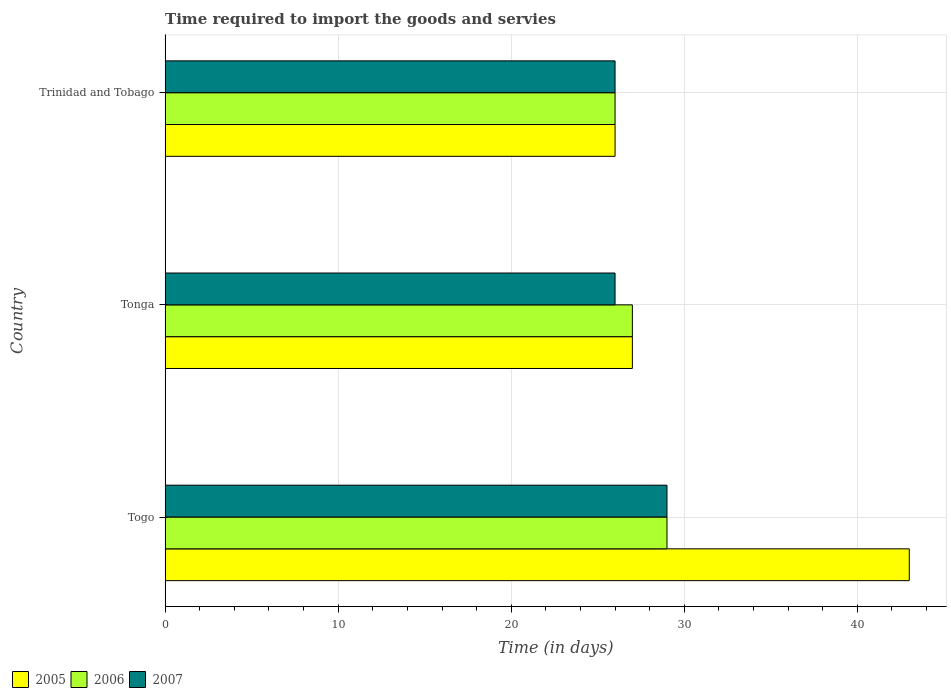How many groups of bars are there?
Your response must be concise. 3. Are the number of bars per tick equal to the number of legend labels?
Make the answer very short. Yes. Are the number of bars on each tick of the Y-axis equal?
Your response must be concise. Yes. How many bars are there on the 3rd tick from the top?
Offer a very short reply. 3. What is the label of the 3rd group of bars from the top?
Offer a terse response. Togo. In which country was the number of days required to import the goods and services in 2005 maximum?
Your response must be concise. Togo. In which country was the number of days required to import the goods and services in 2005 minimum?
Ensure brevity in your answer.  Trinidad and Tobago. What is the difference between the number of days required to import the goods and services in 2006 in Togo and that in Tonga?
Make the answer very short. 2. What is the average number of days required to import the goods and services in 2007 per country?
Your answer should be compact. 27. What is the difference between the number of days required to import the goods and services in 2005 and number of days required to import the goods and services in 2007 in Togo?
Keep it short and to the point. 14. What is the ratio of the number of days required to import the goods and services in 2006 in Togo to that in Tonga?
Make the answer very short. 1.07. Is the number of days required to import the goods and services in 2007 in Tonga less than that in Trinidad and Tobago?
Ensure brevity in your answer.  No. Is the difference between the number of days required to import the goods and services in 2005 in Togo and Trinidad and Tobago greater than the difference between the number of days required to import the goods and services in 2007 in Togo and Trinidad and Tobago?
Give a very brief answer. Yes. What is the difference between the highest and the lowest number of days required to import the goods and services in 2005?
Give a very brief answer. 17. In how many countries, is the number of days required to import the goods and services in 2005 greater than the average number of days required to import the goods and services in 2005 taken over all countries?
Ensure brevity in your answer.  1. What does the 1st bar from the top in Tonga represents?
Make the answer very short. 2007. Are all the bars in the graph horizontal?
Provide a short and direct response. Yes. How many countries are there in the graph?
Give a very brief answer. 3. Does the graph contain any zero values?
Your answer should be compact. No. Does the graph contain grids?
Your answer should be very brief. Yes. Where does the legend appear in the graph?
Provide a short and direct response. Bottom left. How are the legend labels stacked?
Provide a short and direct response. Horizontal. What is the title of the graph?
Your answer should be very brief. Time required to import the goods and servies. What is the label or title of the X-axis?
Your answer should be very brief. Time (in days). What is the label or title of the Y-axis?
Your answer should be compact. Country. What is the Time (in days) of 2006 in Togo?
Offer a very short reply. 29. What is the Time (in days) in 2007 in Togo?
Give a very brief answer. 29. What is the Time (in days) of 2005 in Tonga?
Provide a succinct answer. 27. What is the Time (in days) in 2007 in Tonga?
Your response must be concise. 26. What is the Time (in days) of 2005 in Trinidad and Tobago?
Offer a terse response. 26. What is the Time (in days) of 2007 in Trinidad and Tobago?
Offer a terse response. 26. Across all countries, what is the minimum Time (in days) of 2005?
Offer a very short reply. 26. Across all countries, what is the minimum Time (in days) of 2006?
Your answer should be compact. 26. What is the total Time (in days) of 2005 in the graph?
Give a very brief answer. 96. What is the total Time (in days) in 2007 in the graph?
Offer a very short reply. 81. What is the difference between the Time (in days) in 2005 in Togo and that in Tonga?
Make the answer very short. 16. What is the difference between the Time (in days) in 2006 in Togo and that in Trinidad and Tobago?
Ensure brevity in your answer.  3. What is the difference between the Time (in days) of 2006 in Tonga and that in Trinidad and Tobago?
Your answer should be very brief. 1. What is the difference between the Time (in days) of 2007 in Tonga and that in Trinidad and Tobago?
Your response must be concise. 0. What is the difference between the Time (in days) in 2005 in Togo and the Time (in days) in 2006 in Trinidad and Tobago?
Provide a short and direct response. 17. What is the difference between the Time (in days) of 2005 in Tonga and the Time (in days) of 2007 in Trinidad and Tobago?
Give a very brief answer. 1. What is the difference between the Time (in days) of 2006 in Tonga and the Time (in days) of 2007 in Trinidad and Tobago?
Give a very brief answer. 1. What is the average Time (in days) of 2005 per country?
Provide a succinct answer. 32. What is the average Time (in days) in 2006 per country?
Your answer should be compact. 27.33. What is the difference between the Time (in days) of 2005 and Time (in days) of 2006 in Togo?
Give a very brief answer. 14. What is the difference between the Time (in days) in 2005 and Time (in days) in 2007 in Togo?
Your response must be concise. 14. What is the difference between the Time (in days) of 2005 and Time (in days) of 2006 in Tonga?
Your answer should be compact. 0. What is the difference between the Time (in days) in 2005 and Time (in days) in 2006 in Trinidad and Tobago?
Your answer should be compact. 0. What is the difference between the Time (in days) in 2005 and Time (in days) in 2007 in Trinidad and Tobago?
Your response must be concise. 0. What is the ratio of the Time (in days) in 2005 in Togo to that in Tonga?
Your answer should be compact. 1.59. What is the ratio of the Time (in days) in 2006 in Togo to that in Tonga?
Your answer should be very brief. 1.07. What is the ratio of the Time (in days) of 2007 in Togo to that in Tonga?
Ensure brevity in your answer.  1.12. What is the ratio of the Time (in days) of 2005 in Togo to that in Trinidad and Tobago?
Provide a succinct answer. 1.65. What is the ratio of the Time (in days) in 2006 in Togo to that in Trinidad and Tobago?
Your answer should be very brief. 1.12. What is the ratio of the Time (in days) of 2007 in Togo to that in Trinidad and Tobago?
Offer a terse response. 1.12. What is the ratio of the Time (in days) in 2005 in Tonga to that in Trinidad and Tobago?
Provide a short and direct response. 1.04. What is the ratio of the Time (in days) in 2006 in Tonga to that in Trinidad and Tobago?
Your answer should be very brief. 1.04. What is the ratio of the Time (in days) in 2007 in Tonga to that in Trinidad and Tobago?
Give a very brief answer. 1. What is the difference between the highest and the second highest Time (in days) in 2005?
Your answer should be compact. 16. What is the difference between the highest and the lowest Time (in days) in 2006?
Provide a short and direct response. 3. What is the difference between the highest and the lowest Time (in days) of 2007?
Provide a short and direct response. 3. 